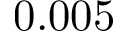<formula> <loc_0><loc_0><loc_500><loc_500>0 . 0 0 5</formula> 